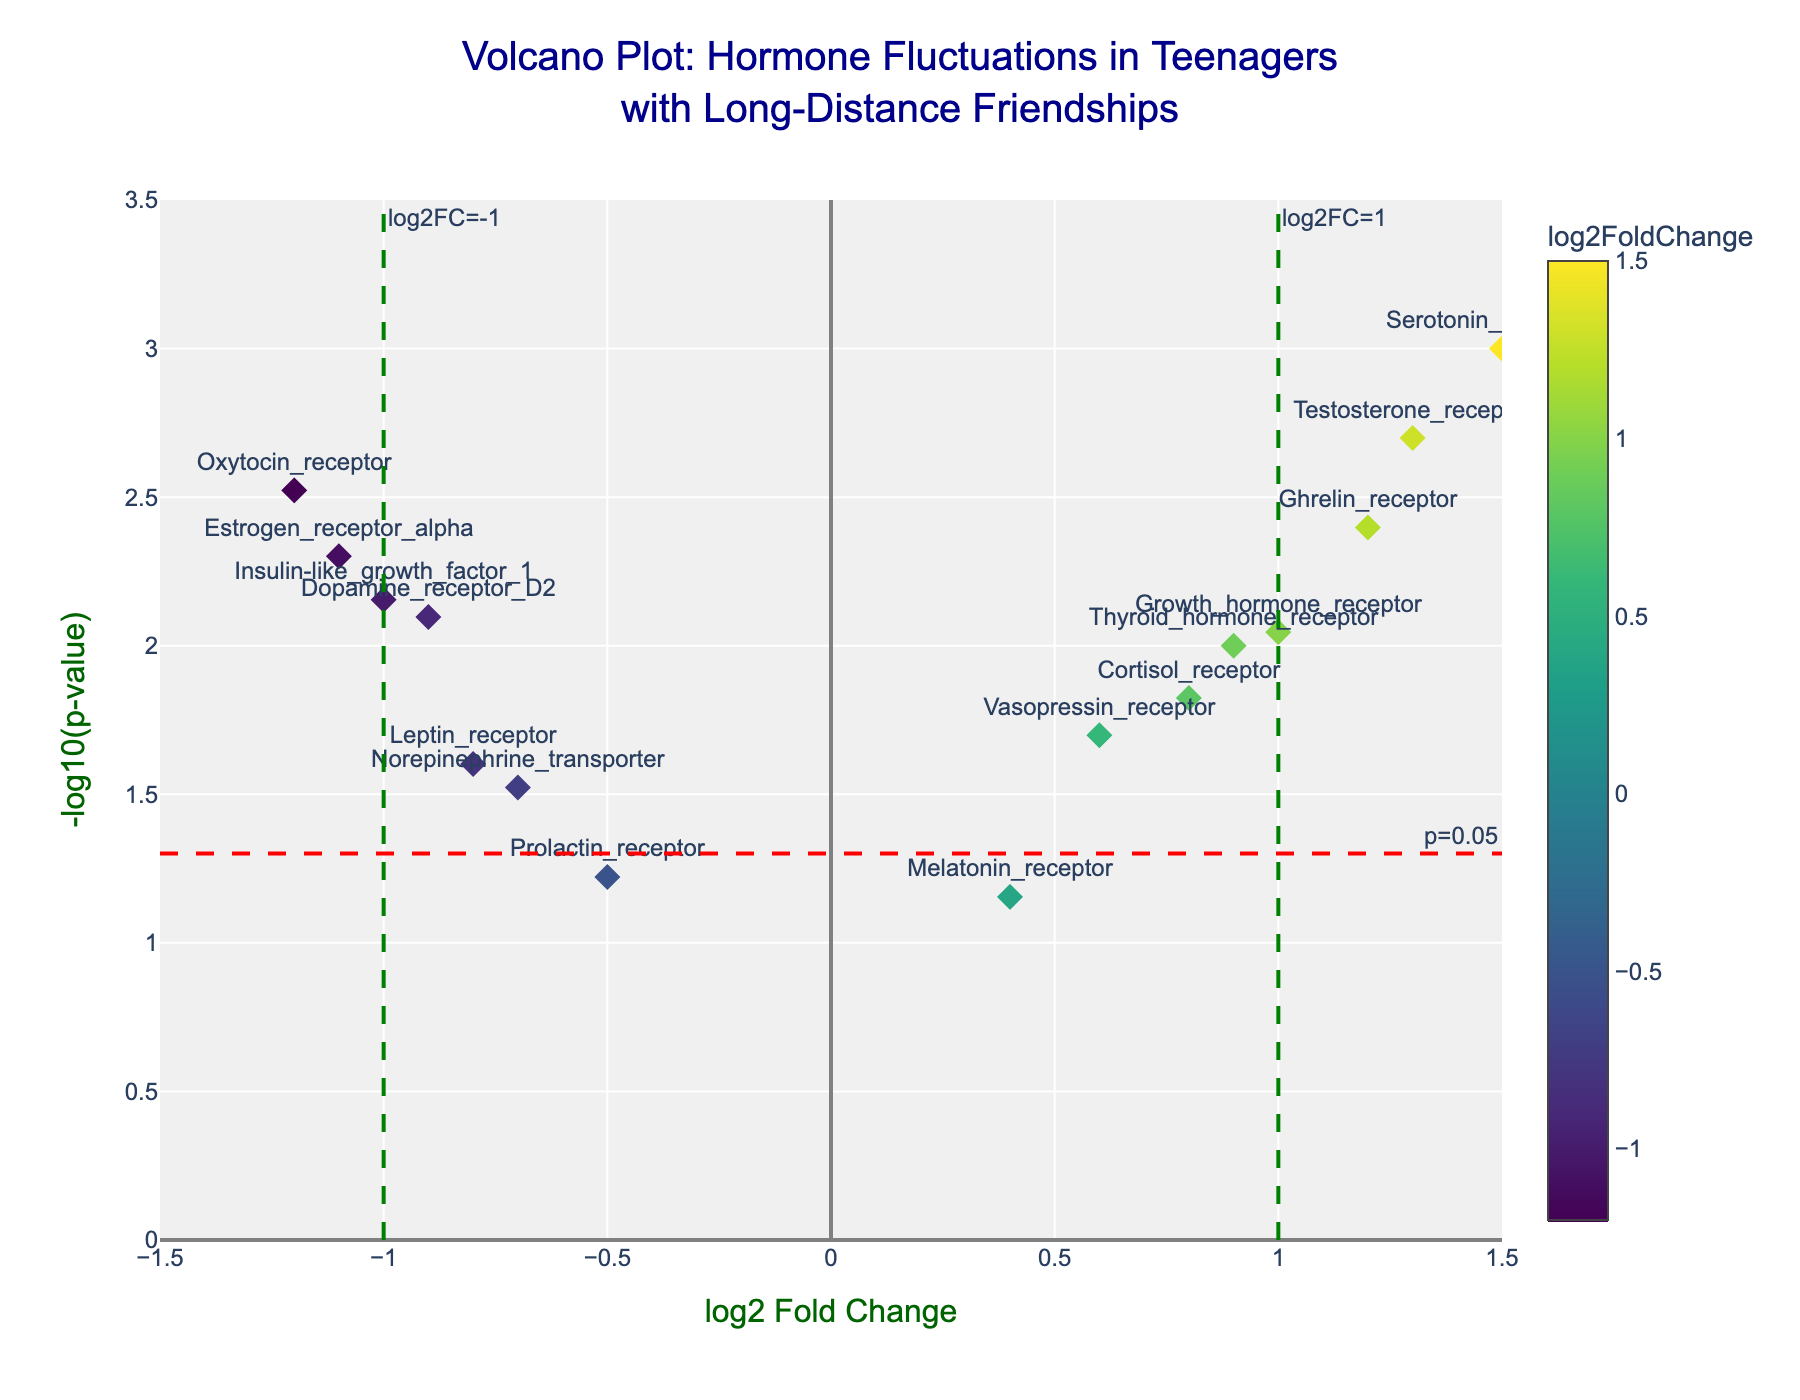What's the title of the plot? The plot is titled prominently at the top.
Answer: Volcano Plot: Hormone Fluctuations in Teenagers with Long-Distance Friendships What does the x-axis represent? The x-axis title is specified, indicating what it represents.
Answer: log2 Fold Change What does the y-axis represent? The y-axis title shows what it represents.
Answer: -log10(p-value) How many data points are there on the plot? Each gene contributes a marker to the plot, and counting them gives the total.
Answer: 15 Which hormone receptor has the highest log2 fold change? By comparing the x-axis positions, the furthest to the right indicates the highest log2 fold change.
Answer: Serotonin_transporter Which hormones have a log2 fold change less than -1? Hormones with log2 fold changes less than -1 are located to the left of the vertical green line at -1.
Answer: Oxytocin_receptor, Estrogen_receptor_alpha, Insulin-like_growth_factor_1 Which hormone has the smallest p-value? The smallest p-value corresponds to the highest value on the y-axis.
Answer: Serotonin_transporter Compare the log2 fold change of Testosterone_receptor and Cortisol_receptor. Which one is higher? Comparing their x-axis positions, the one further to the right has the higher log2 fold change.
Answer: Testosterone_receptor Are there any hormones with a p-value above 0.05? Points below the red dashed line at y=-log10(0.05) have a p-value above 0.05.
Answer: Melatonin_receptor, Prolactin_receptor How many hormone receptors have a log2 fold change between -0.5 and 0.5? Count the points within the range between -0.5 and 0.5 on the x-axis.
Answer: 3 